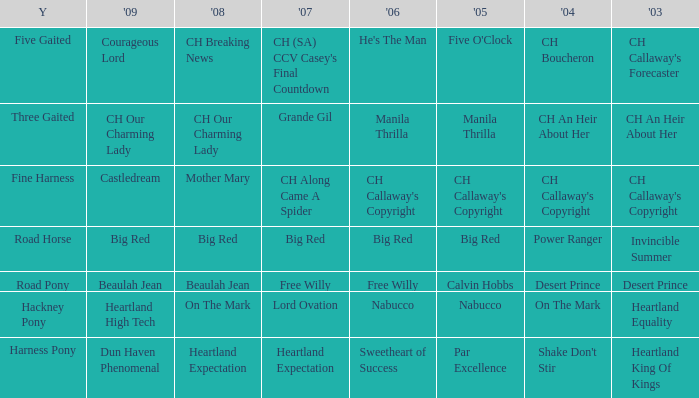What is the 2008 for 2009 heartland high tech? On The Mark. 